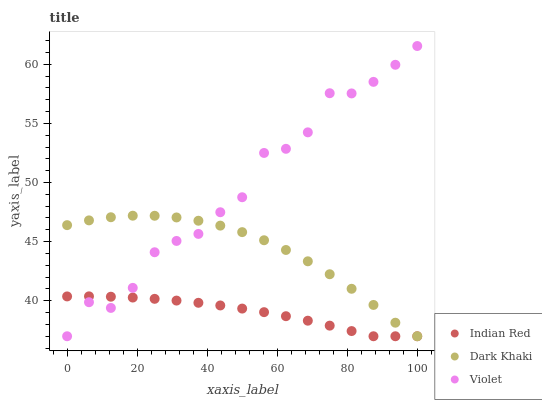Does Indian Red have the minimum area under the curve?
Answer yes or no. Yes. Does Violet have the maximum area under the curve?
Answer yes or no. Yes. Does Violet have the minimum area under the curve?
Answer yes or no. No. Does Indian Red have the maximum area under the curve?
Answer yes or no. No. Is Indian Red the smoothest?
Answer yes or no. Yes. Is Violet the roughest?
Answer yes or no. Yes. Is Violet the smoothest?
Answer yes or no. No. Is Indian Red the roughest?
Answer yes or no. No. Does Dark Khaki have the lowest value?
Answer yes or no. Yes. Does Violet have the highest value?
Answer yes or no. Yes. Does Indian Red have the highest value?
Answer yes or no. No. Does Dark Khaki intersect Indian Red?
Answer yes or no. Yes. Is Dark Khaki less than Indian Red?
Answer yes or no. No. Is Dark Khaki greater than Indian Red?
Answer yes or no. No. 